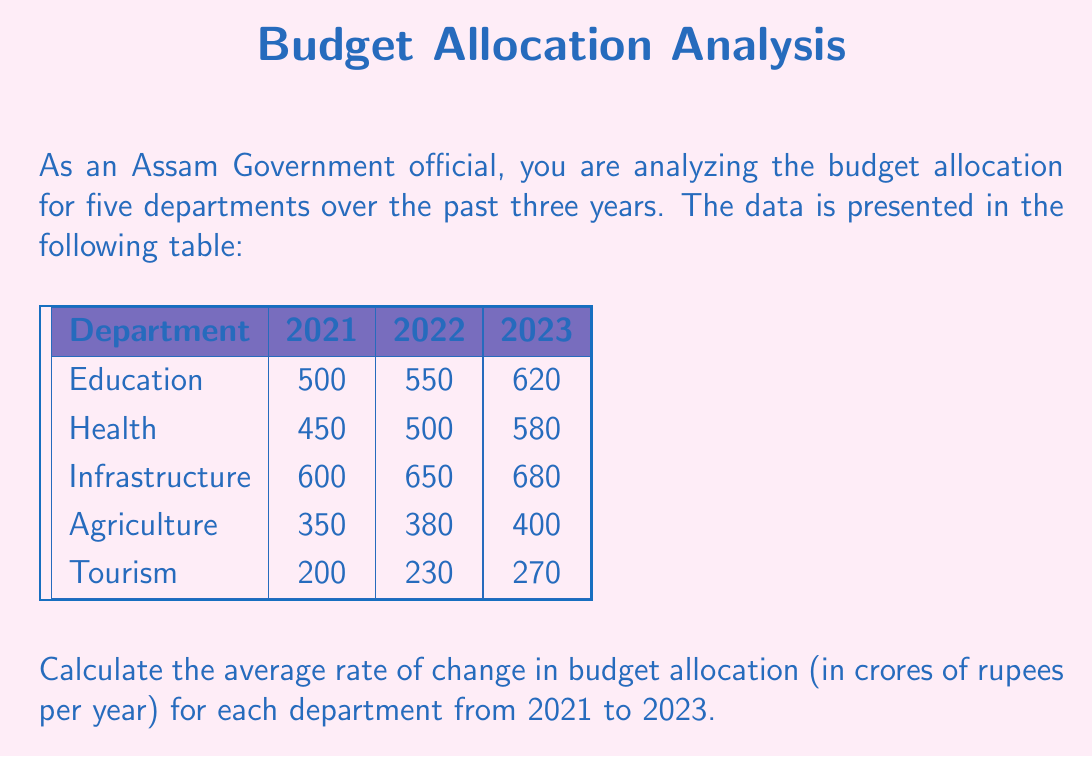Teach me how to tackle this problem. To calculate the average rate of change in budget allocation for each department from 2021 to 2023, we'll use the formula:

$$ \text{Average rate of change} = \frac{\text{Change in budget}}{\text{Change in time}} = \frac{\text{Budget}_{2023} - \text{Budget}_{2021}}{2023 - 2021} $$

Let's calculate for each department:

1. Education:
   $$ \frac{620 - 500}{2} = \frac{120}{2} = 60 \text{ crores/year} $$

2. Health:
   $$ \frac{580 - 450}{2} = \frac{130}{2} = 65 \text{ crores/year} $$

3. Infrastructure:
   $$ \frac{680 - 600}{2} = \frac{80}{2} = 40 \text{ crores/year} $$

4. Agriculture:
   $$ \frac{400 - 350}{2} = \frac{50}{2} = 25 \text{ crores/year} $$

5. Tourism:
   $$ \frac{270 - 200}{2} = \frac{70}{2} = 35 \text{ crores/year} $$

These calculations give us the average increase in budget allocation per year for each department over the two-year period from 2021 to 2023.
Answer: Education: 60, Health: 65, Infrastructure: 40, Agriculture: 25, Tourism: 35 (all in crores of rupees per year) 